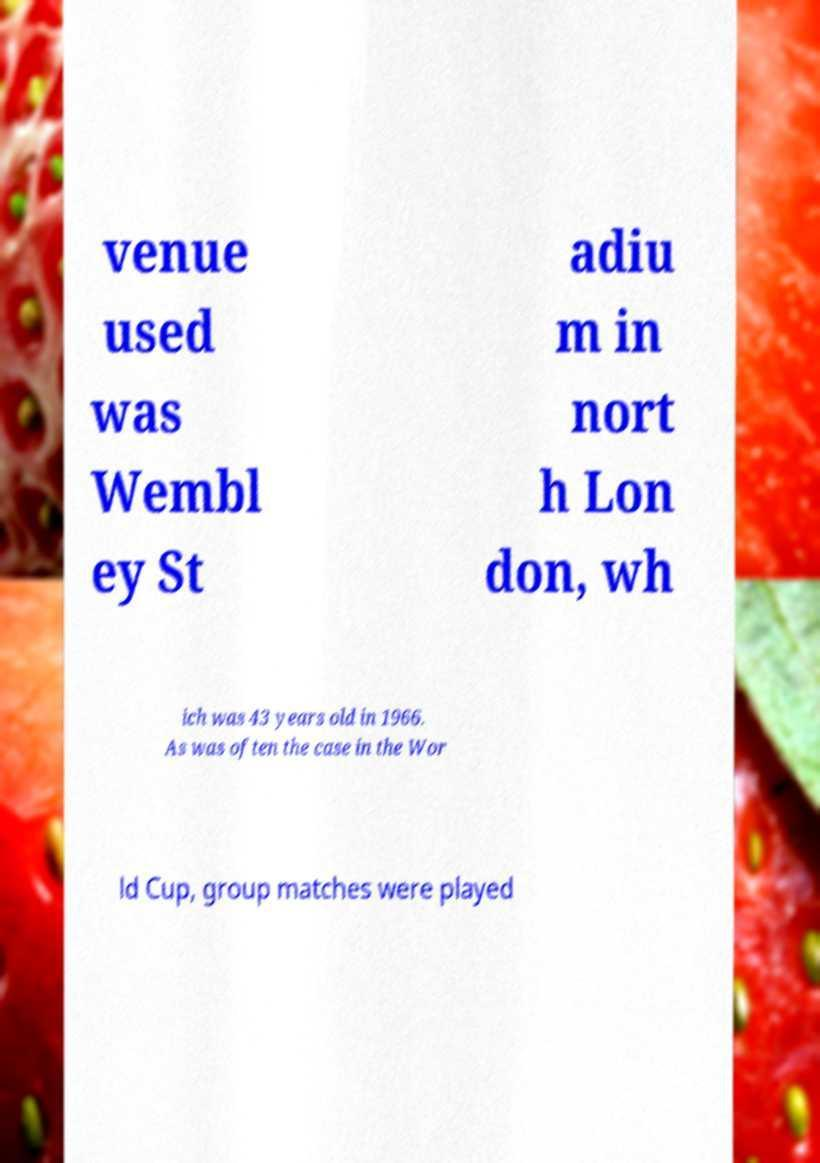I need the written content from this picture converted into text. Can you do that? venue used was Wembl ey St adiu m in nort h Lon don, wh ich was 43 years old in 1966. As was often the case in the Wor ld Cup, group matches were played 